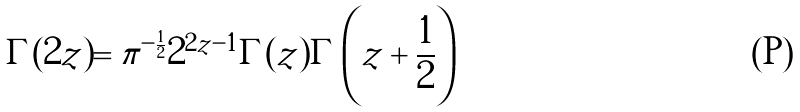<formula> <loc_0><loc_0><loc_500><loc_500>\Gamma ( 2 z ) = \pi ^ { - \frac { 1 } { 2 } } 2 ^ { 2 z - 1 } \Gamma ( z ) \Gamma \left ( z + \frac { 1 } { 2 } \right )</formula> 